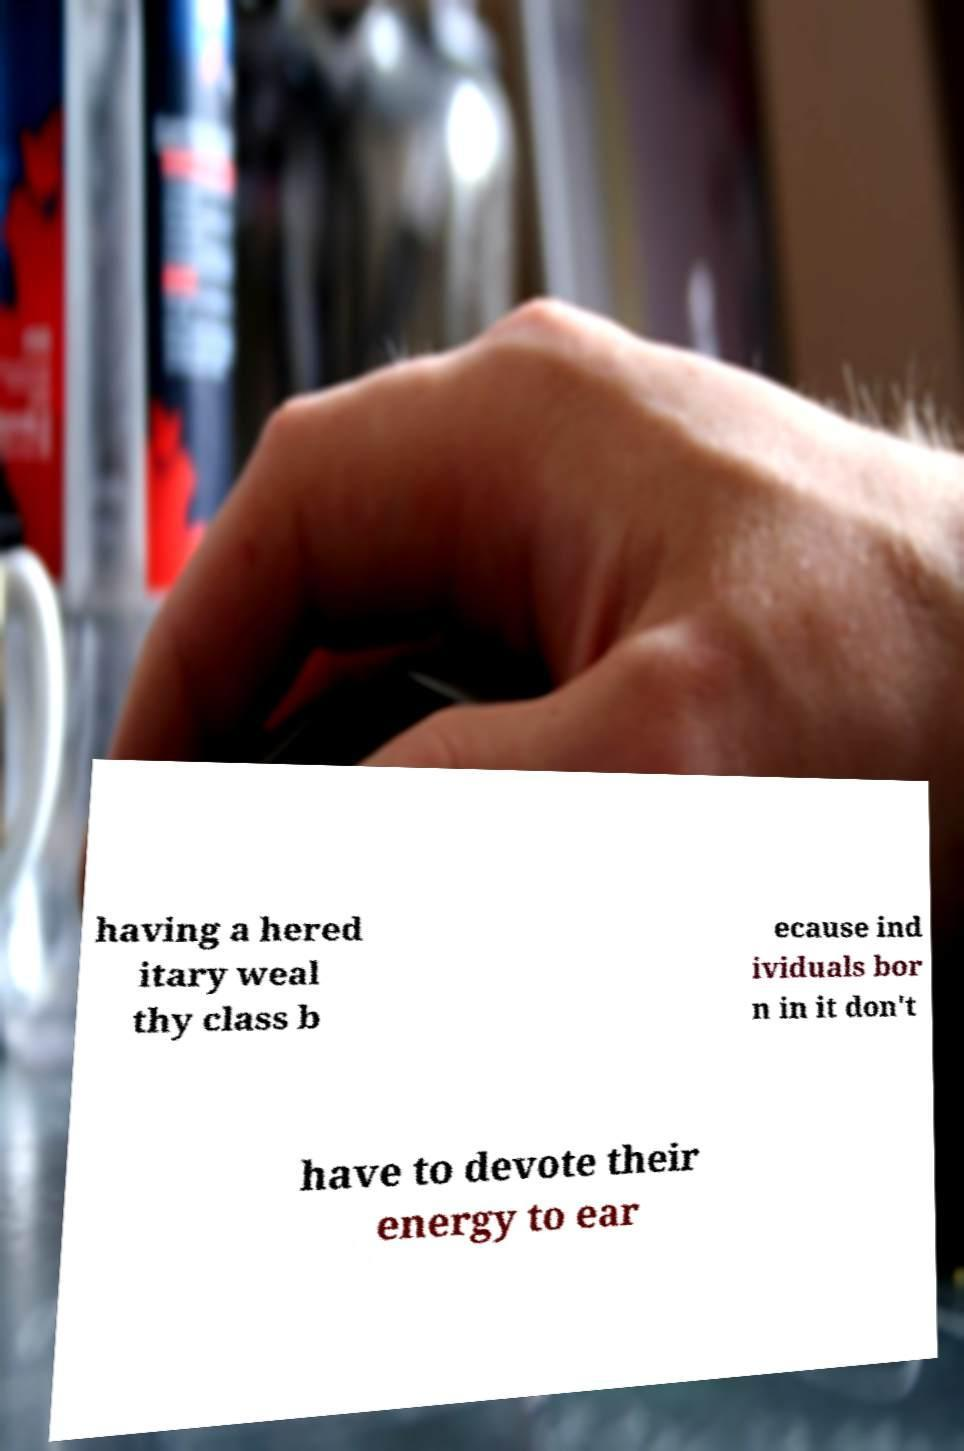There's text embedded in this image that I need extracted. Can you transcribe it verbatim? having a hered itary weal thy class b ecause ind ividuals bor n in it don't have to devote their energy to ear 